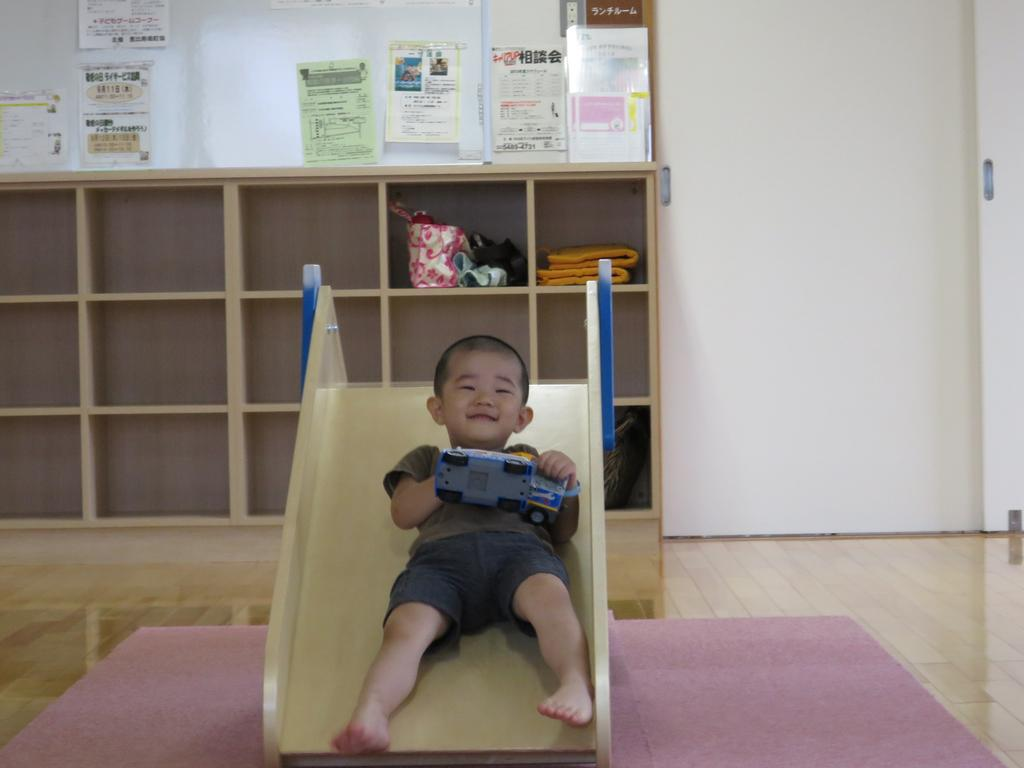What is the main subject of the image? The main subject of the image is a kid. What is the kid doing in the image? The kid is sliding in the image. What is the kid holding while sliding? The kid is holding a toy in the image. What can be seen on the rack in the image? The rack has a bag on it and a few objects on it. What is present on the wall in the image? There are posters on the wall in the image. Is there any entrance or exit visible in the image? Yes, the wall has a door in the image. What type of eggs can be seen in the image? There are no eggs present in the image. How does the office furniture contribute to the taste of the toy the kid is holding? There is no office furniture or taste mentioned in the image; it features a kid sliding while holding a toy. 